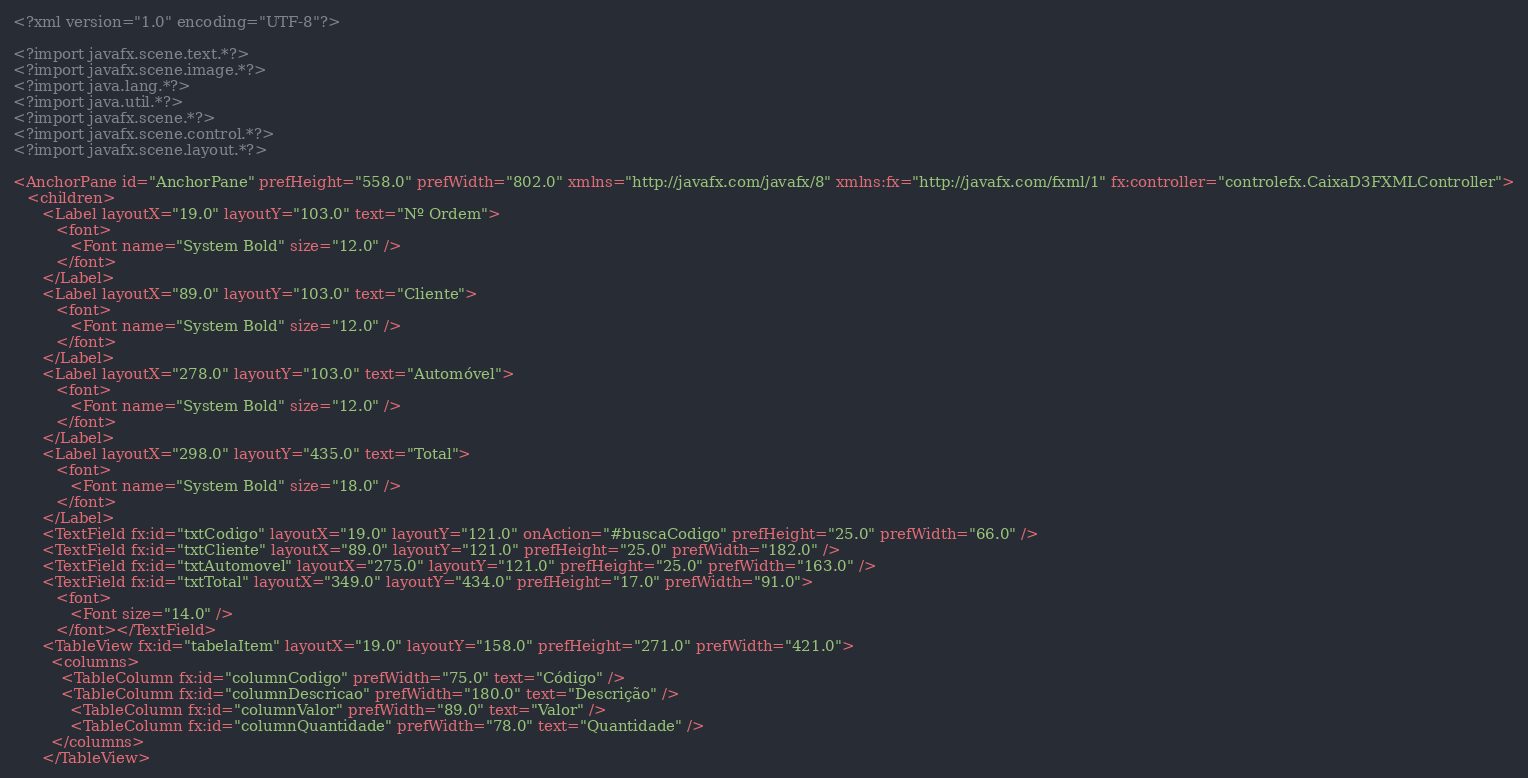<code> <loc_0><loc_0><loc_500><loc_500><_XML_><?xml version="1.0" encoding="UTF-8"?>

<?import javafx.scene.text.*?>
<?import javafx.scene.image.*?>
<?import java.lang.*?>
<?import java.util.*?>
<?import javafx.scene.*?>
<?import javafx.scene.control.*?>
<?import javafx.scene.layout.*?>

<AnchorPane id="AnchorPane" prefHeight="558.0" prefWidth="802.0" xmlns="http://javafx.com/javafx/8" xmlns:fx="http://javafx.com/fxml/1" fx:controller="controlefx.CaixaD3FXMLController">
   <children>
      <Label layoutX="19.0" layoutY="103.0" text="Nº Ordem">
         <font>
            <Font name="System Bold" size="12.0" />
         </font>
      </Label>
      <Label layoutX="89.0" layoutY="103.0" text="Cliente">
         <font>
            <Font name="System Bold" size="12.0" />
         </font>
      </Label>
      <Label layoutX="278.0" layoutY="103.0" text="Automóvel">
         <font>
            <Font name="System Bold" size="12.0" />
         </font>
      </Label>
      <Label layoutX="298.0" layoutY="435.0" text="Total">
         <font>
            <Font name="System Bold" size="18.0" />
         </font>
      </Label>
      <TextField fx:id="txtCodigo" layoutX="19.0" layoutY="121.0" onAction="#buscaCodigo" prefHeight="25.0" prefWidth="66.0" />
      <TextField fx:id="txtCliente" layoutX="89.0" layoutY="121.0" prefHeight="25.0" prefWidth="182.0" />
      <TextField fx:id="txtAutomovel" layoutX="275.0" layoutY="121.0" prefHeight="25.0" prefWidth="163.0" />
      <TextField fx:id="txtTotal" layoutX="349.0" layoutY="434.0" prefHeight="17.0" prefWidth="91.0">
         <font>
            <Font size="14.0" />
         </font></TextField>
      <TableView fx:id="tabelaItem" layoutX="19.0" layoutY="158.0" prefHeight="271.0" prefWidth="421.0">
        <columns>
          <TableColumn fx:id="columnCodigo" prefWidth="75.0" text="Código" />
          <TableColumn fx:id="columnDescricao" prefWidth="180.0" text="Descrição" />
            <TableColumn fx:id="columnValor" prefWidth="89.0" text="Valor" />
            <TableColumn fx:id="columnQuantidade" prefWidth="78.0" text="Quantidade" />
        </columns>
      </TableView></code> 